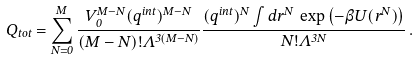<formula> <loc_0><loc_0><loc_500><loc_500>Q _ { t o t } = \sum _ { N = 0 } ^ { M } \frac { V _ { 0 } ^ { M - N } ( q ^ { i n t } ) ^ { M - N } } { ( M - N ) ! \Lambda ^ { 3 ( M - N ) } } \frac { ( q ^ { i n t } ) ^ { N } \int d { r } ^ { N } \, \exp \left ( - \beta U ( r ^ { N } ) \right ) } { N ! \Lambda ^ { 3 N } } \, .</formula> 